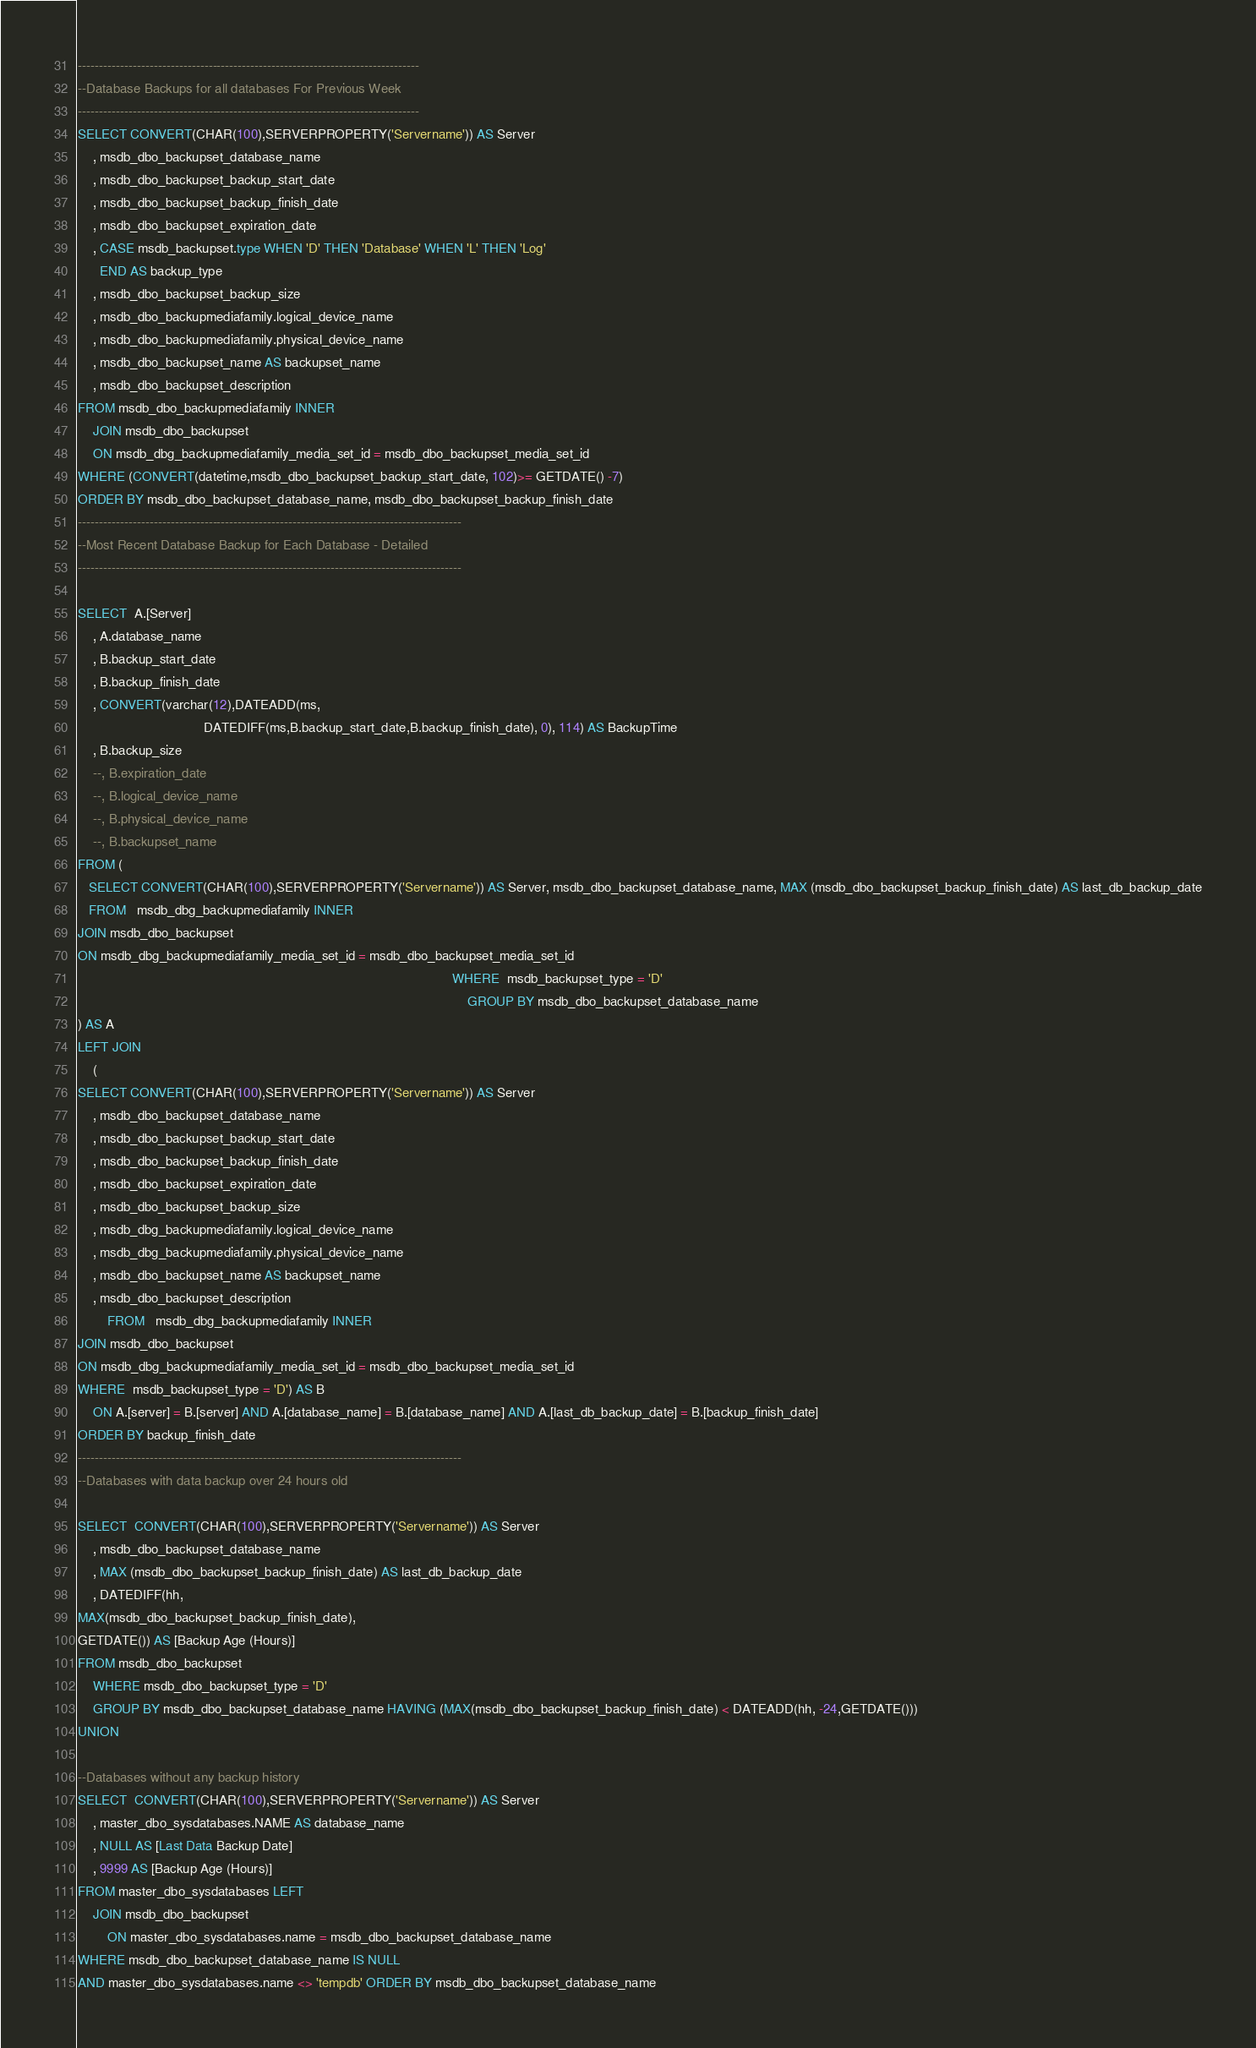Convert code to text. <code><loc_0><loc_0><loc_500><loc_500><_SQL_>---------------------------------------------------------------------------------
--Database Backups for all databases For Previous Week
---------------------------------------------------------------------------------
SELECT CONVERT(CHAR(100),SERVERPROPERTY('Servername')) AS Server
    , msdb_dbo_backupset_database_name
    , msdb_dbo_backupset_backup_start_date
    , msdb_dbo_backupset_backup_finish_date
    , msdb_dbo_backupset_expiration_date
    , CASE msdb_backupset.type WHEN 'D' THEN 'Database' WHEN 'L' THEN 'Log'
      END AS backup_type
    , msdb_dbo_backupset_backup_size
    , msdb_dbo_backupmediafamily.logical_device_name
    , msdb_dbo_backupmediafamily.physical_device_name
    , msdb_dbo_backupset_name AS backupset_name
    , msdb_dbo_backupset_description
FROM msdb_dbo_backupmediafamily INNER
    JOIN msdb_dbo_backupset
    ON msdb_dbg_backupmediafamily_media_set_id = msdb_dbo_backupset_media_set_id
WHERE (CONVERT(datetime,msdb_dbo_backupset_backup_start_date, 102)>= GETDATE() -7)
ORDER BY msdb_dbo_backupset_database_name, msdb_dbo_backupset_backup_finish_date
-------------------------------------------------------------------------------------------
--Most Recent Database Backup for Each Database - Detailed
-------------------------------------------------------------------------------------------    

SELECT  A.[Server]
    , A.database_name
    , B.backup_start_date
    , B.backup_finish_date
    , CONVERT(varchar(12),DATEADD(ms,
                                  DATEDIFF(ms,B.backup_start_date,B.backup_finish_date), 0), 114) AS BackupTime
    , B.backup_size
    --, B.expiration_date
    --, B.logical_device_name
    --, B.physical_device_name
    --, B.backupset_name
FROM (
   SELECT CONVERT(CHAR(100),SERVERPROPERTY('Servername')) AS Server, msdb_dbo_backupset_database_name, MAX (msdb_dbo_backupset_backup_finish_date) AS last_db_backup_date
   FROM   msdb_dbg_backupmediafamily INNER
JOIN msdb_dbo_backupset
ON msdb_dbg_backupmediafamily_media_set_id = msdb_dbo_backupset_media_set_id
                                                                                                     WHERE  msdb_backupset_type = 'D'
                                                                                                         GROUP BY msdb_dbo_backupset_database_name
) AS A
LEFT JOIN
    (
SELECT CONVERT(CHAR(100),SERVERPROPERTY('Servername')) AS Server
    , msdb_dbo_backupset_database_name
    , msdb_dbo_backupset_backup_start_date
    , msdb_dbo_backupset_backup_finish_date
    , msdb_dbo_backupset_expiration_date
    , msdb_dbo_backupset_backup_size
    , msdb_dbg_backupmediafamily.logical_device_name
    , msdb_dbg_backupmediafamily.physical_device_name
    , msdb_dbo_backupset_name AS backupset_name
    , msdb_dbo_backupset_description
        FROM   msdb_dbg_backupmediafamily INNER
JOIN msdb_dbo_backupset
ON msdb_dbg_backupmediafamily_media_set_id = msdb_dbo_backupset_media_set_id
WHERE  msdb_backupset_type = 'D') AS B
    ON A.[server] = B.[server] AND A.[database_name] = B.[database_name] AND A.[last_db_backup_date] = B.[backup_finish_date]
ORDER BY backup_finish_date
-------------------------------------------------------------------------------------------
--Databases with data backup over 24 hours old

SELECT  CONVERT(CHAR(100),SERVERPROPERTY('Servername')) AS Server
    , msdb_dbo_backupset_database_name
    , MAX (msdb_dbo_backupset_backup_finish_date) AS last_db_backup_date
    , DATEDIFF(hh,
MAX(msdb_dbo_backupset_backup_finish_date),
GETDATE()) AS [Backup Age (Hours)]
FROM msdb_dbo_backupset
    WHERE msdb_dbo_backupset_type = 'D'
    GROUP BY msdb_dbo_backupset_database_name HAVING (MAX(msdb_dbo_backupset_backup_finish_date) < DATEADD(hh, -24,GETDATE()))
UNION 

--Databases without any backup history
SELECT  CONVERT(CHAR(100),SERVERPROPERTY('Servername')) AS Server
    , master_dbo_sysdatabases.NAME AS database_name
    , NULL AS [Last Data Backup Date]
    , 9999 AS [Backup Age (Hours)]
FROM master_dbo_sysdatabases LEFT
    JOIN msdb_dbo_backupset
        ON master_dbo_sysdatabases.name = msdb_dbo_backupset_database_name
WHERE msdb_dbo_backupset_database_name IS NULL
AND master_dbo_sysdatabases.name <> 'tempdb' ORDER BY msdb_dbo_backupset_database_name</code> 